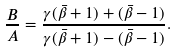<formula> <loc_0><loc_0><loc_500><loc_500>\frac { B } { A } = \frac { \gamma ( \bar { \beta } + 1 ) + ( \bar { \beta } - 1 ) } { \gamma ( \bar { \beta } + 1 ) - ( \bar { \beta } - 1 ) } .</formula> 